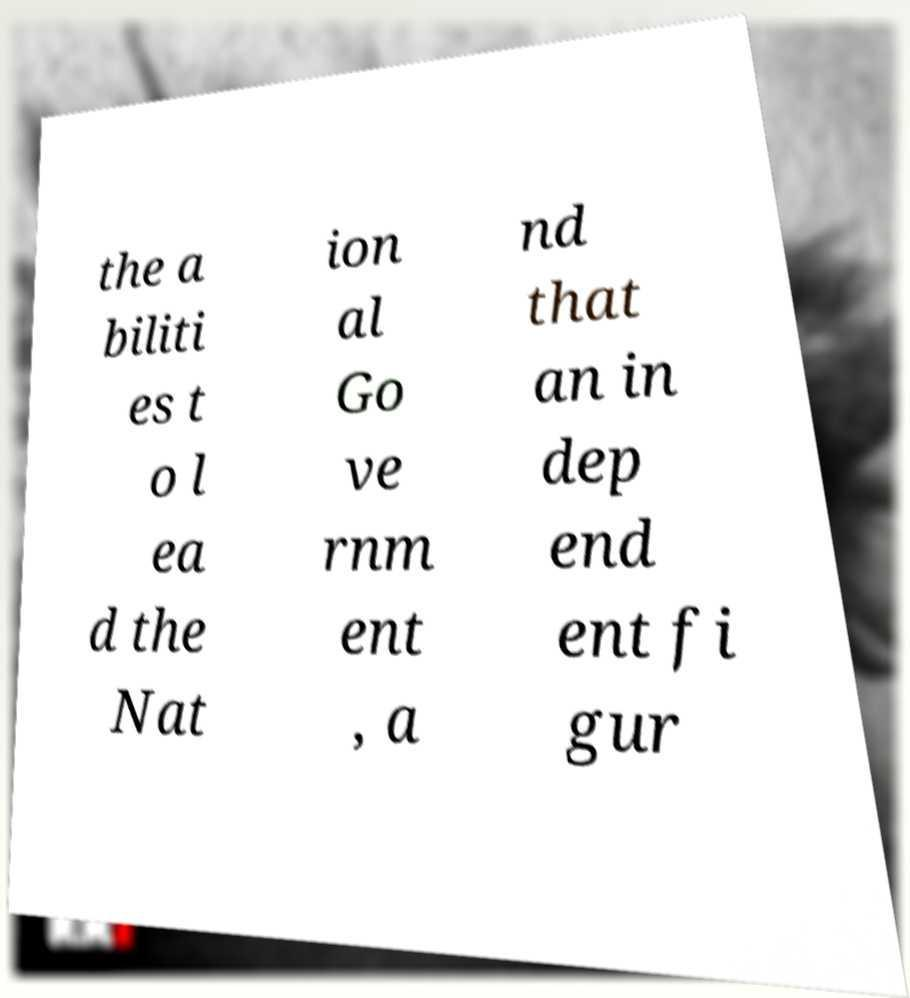Could you extract and type out the text from this image? the a biliti es t o l ea d the Nat ion al Go ve rnm ent , a nd that an in dep end ent fi gur 